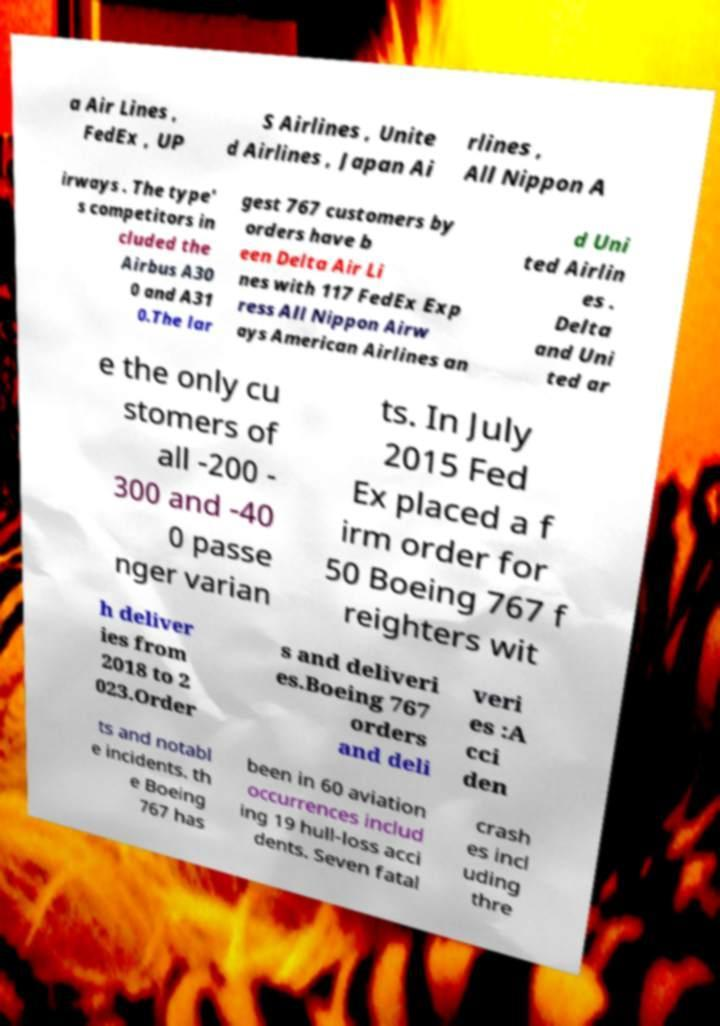For documentation purposes, I need the text within this image transcribed. Could you provide that? a Air Lines , FedEx , UP S Airlines , Unite d Airlines , Japan Ai rlines , All Nippon A irways . The type' s competitors in cluded the Airbus A30 0 and A31 0.The lar gest 767 customers by orders have b een Delta Air Li nes with 117 FedEx Exp ress All Nippon Airw ays American Airlines an d Uni ted Airlin es . Delta and Uni ted ar e the only cu stomers of all -200 - 300 and -40 0 passe nger varian ts. In July 2015 Fed Ex placed a f irm order for 50 Boeing 767 f reighters wit h deliver ies from 2018 to 2 023.Order s and deliveri es.Boeing 767 orders and deli veri es :A cci den ts and notabl e incidents. th e Boeing 767 has been in 60 aviation occurrences includ ing 19 hull-loss acci dents. Seven fatal crash es incl uding thre 